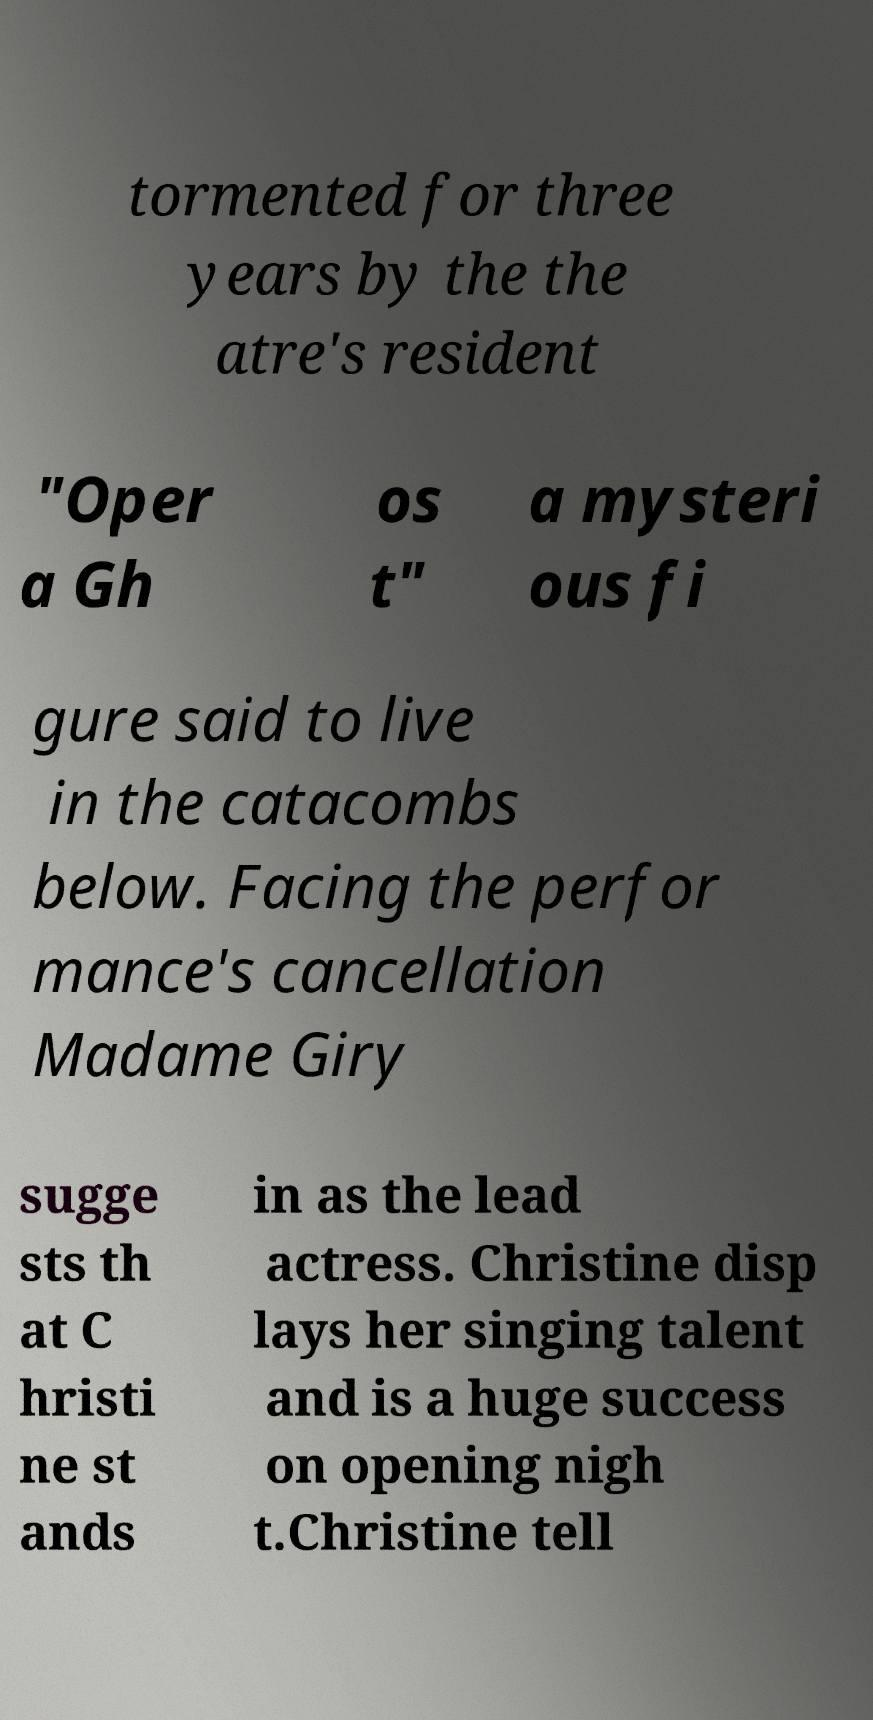Could you assist in decoding the text presented in this image and type it out clearly? tormented for three years by the the atre's resident "Oper a Gh os t" a mysteri ous fi gure said to live in the catacombs below. Facing the perfor mance's cancellation Madame Giry sugge sts th at C hristi ne st ands in as the lead actress. Christine disp lays her singing talent and is a huge success on opening nigh t.Christine tell 